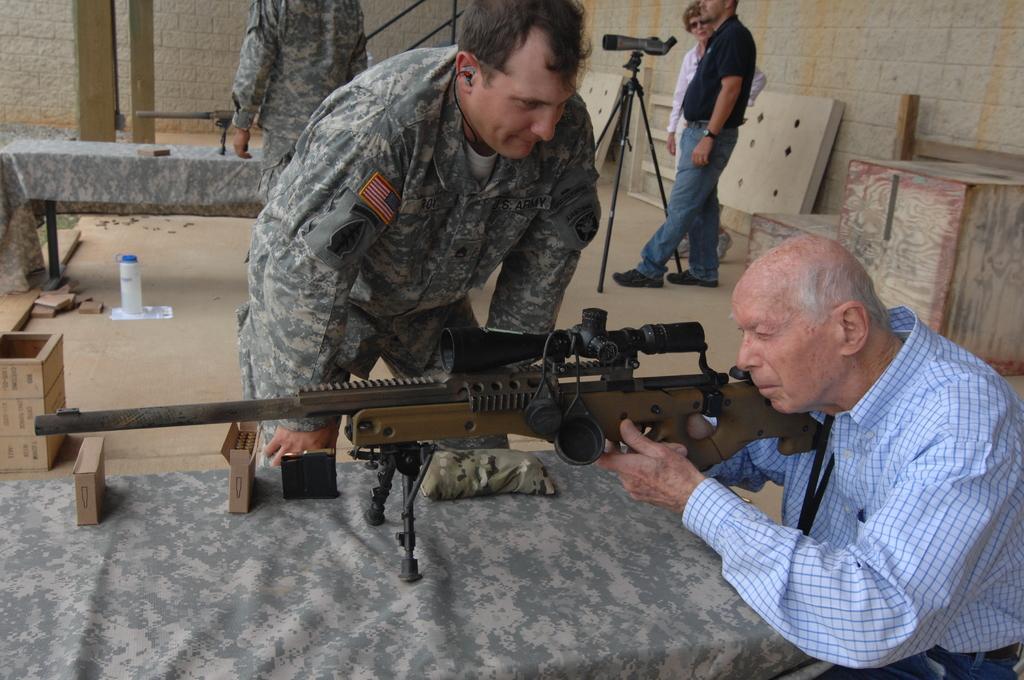How would you summarize this image in a sentence or two? In the picture we can see a man holding a gun, which is one the table and aiming something and beside it, we can see an army man and looking at him and behind him also we can see an army man near the table and gun on it and behind them, we can see two people are standing with camera on tripod and in the background we can see a railing, wall and two pillars near it. 